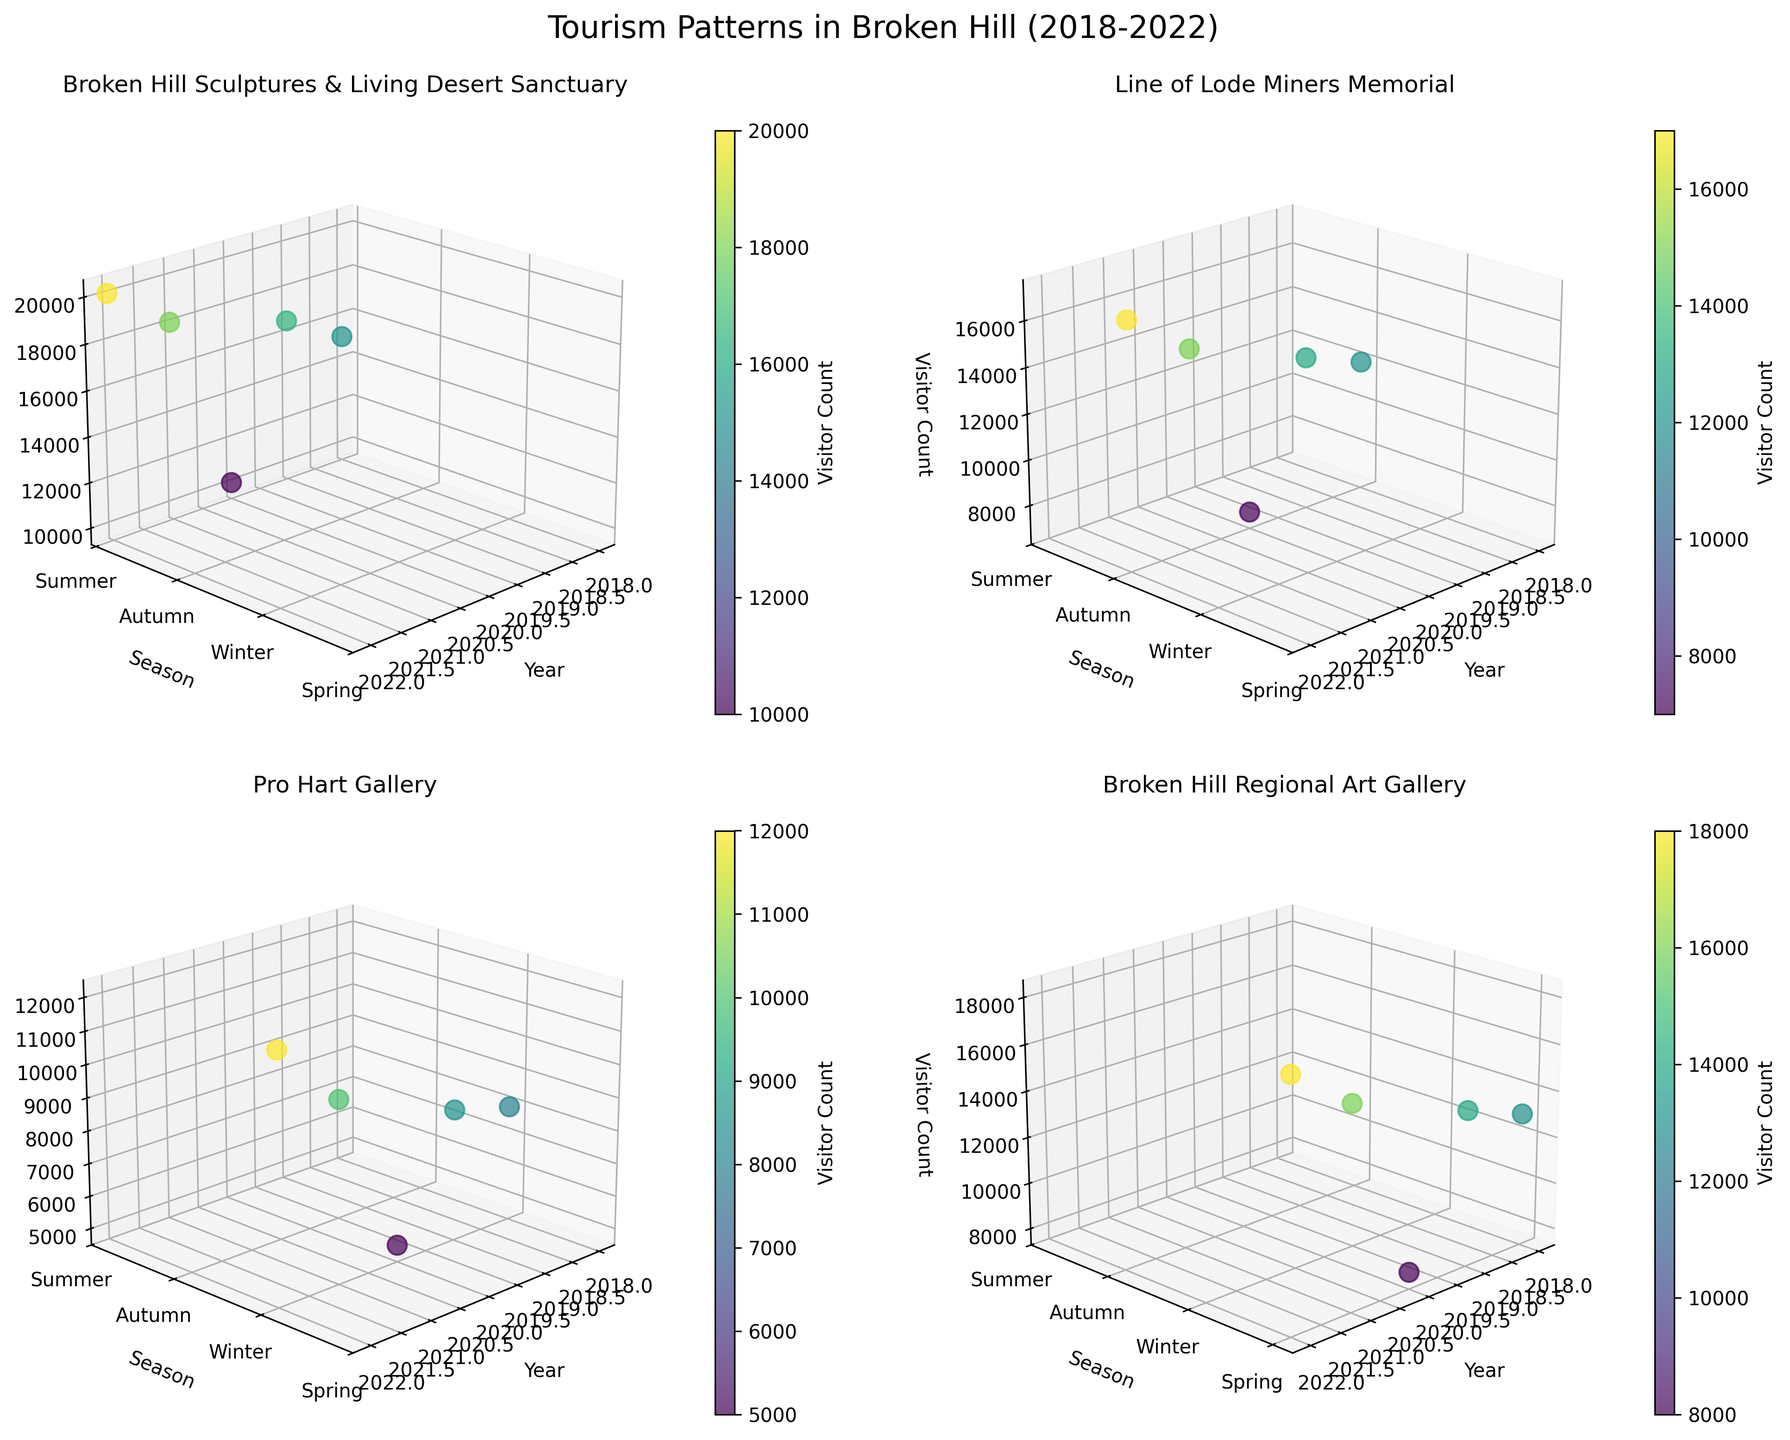How many 3D subplots are there in the figure? There are four unique attractions shown, each having a separate subplot. By counting them, we find four subplots.
Answer: Four Which season has the highest visitor count for the Broken Hill Sculptures & Living Desert Sanctuary? Look at the subplot titled "Broken Hill Sculptures & Living Desert Sanctuary" and observe the z-axis for each season. Summer shows the highest visitor count.
Answer: Summer Compare visitor numbers for Pro Hart Gallery during Winter across the years. Which year experienced the highest visitor count? Focus on the "Pro Hart Gallery" subplot and examine the data points for Winter (indicated on the y-axis). The year with the highest z-axis value is 2022.
Answer: 2022 What is the overall trend of visitor counts to Line of Lode Miners Memorial from 2018 to 2022? Check the subplot for "Line of Lode Miners Memorial" and observe the z-axis values across the years. Visitor counts generally show an increasing trend over the years.
Answer: Increasing Which attraction had the lowest visitor count in Spring 2020? Look at the subplots and identify the data points for Spring 2020. Compare the z-axis values and observe that "Broken Hill Regional Art Gallery" has the lowest visitor count.
Answer: Broken Hill Regional Art Gallery How does the visitor count for Broken Hill Regional Art Gallery in Spring 2021 compare to Spring 2020? Focus on the "Broken Hill Regional Art Gallery" subplot and observe the z-axis values for Spring 2020 and Spring 2021. The visitor count is notably higher in Spring 2021.
Answer: Higher What is the most visited attraction in Summer 2022? Check the subplots for Summer 2022 and compare the z-axis values. The "Broken Hill Sculptures & Living Desert Sanctuary" has the highest visitor count.
Answer: Broken Hill Sculptures & Living Desert Sanctuary Compare the visitor count to Pro Hart Gallery in Winter 2019 to Winter 2020. Which year had a higher visitor count? Focus on the "Pro Hart Gallery" subplot and examine the z-axis values for Winter 2019 and 2020. The visitor count is higher in 2019.
Answer: 2019 